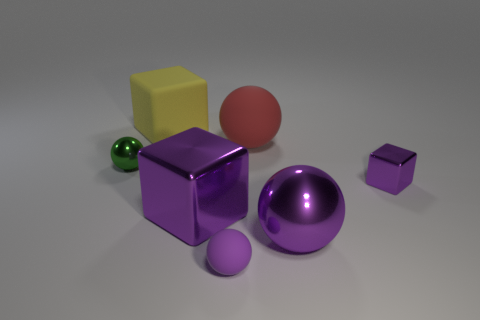Is the number of cyan things greater than the number of tiny purple cubes?
Your answer should be compact. No. What is the size of the red matte sphere that is behind the matte sphere in front of the tiny object on the right side of the big red ball?
Keep it short and to the point. Large. How big is the shiny ball in front of the green shiny ball?
Make the answer very short. Large. What number of things are either small purple balls or purple metal blocks that are on the left side of the purple matte sphere?
Ensure brevity in your answer.  2. How many other things are there of the same size as the red rubber thing?
Provide a succinct answer. 3. There is another small thing that is the same shape as the purple matte object; what is it made of?
Ensure brevity in your answer.  Metal. Is the number of small purple shiny cubes that are on the left side of the tiny purple rubber ball greater than the number of large yellow objects?
Your answer should be very brief. No. Is there anything else of the same color as the large rubber cube?
Provide a succinct answer. No. There is a tiny purple thing that is made of the same material as the large red thing; what is its shape?
Offer a very short reply. Sphere. Do the big sphere in front of the small metal cube and the yellow block have the same material?
Make the answer very short. No. 